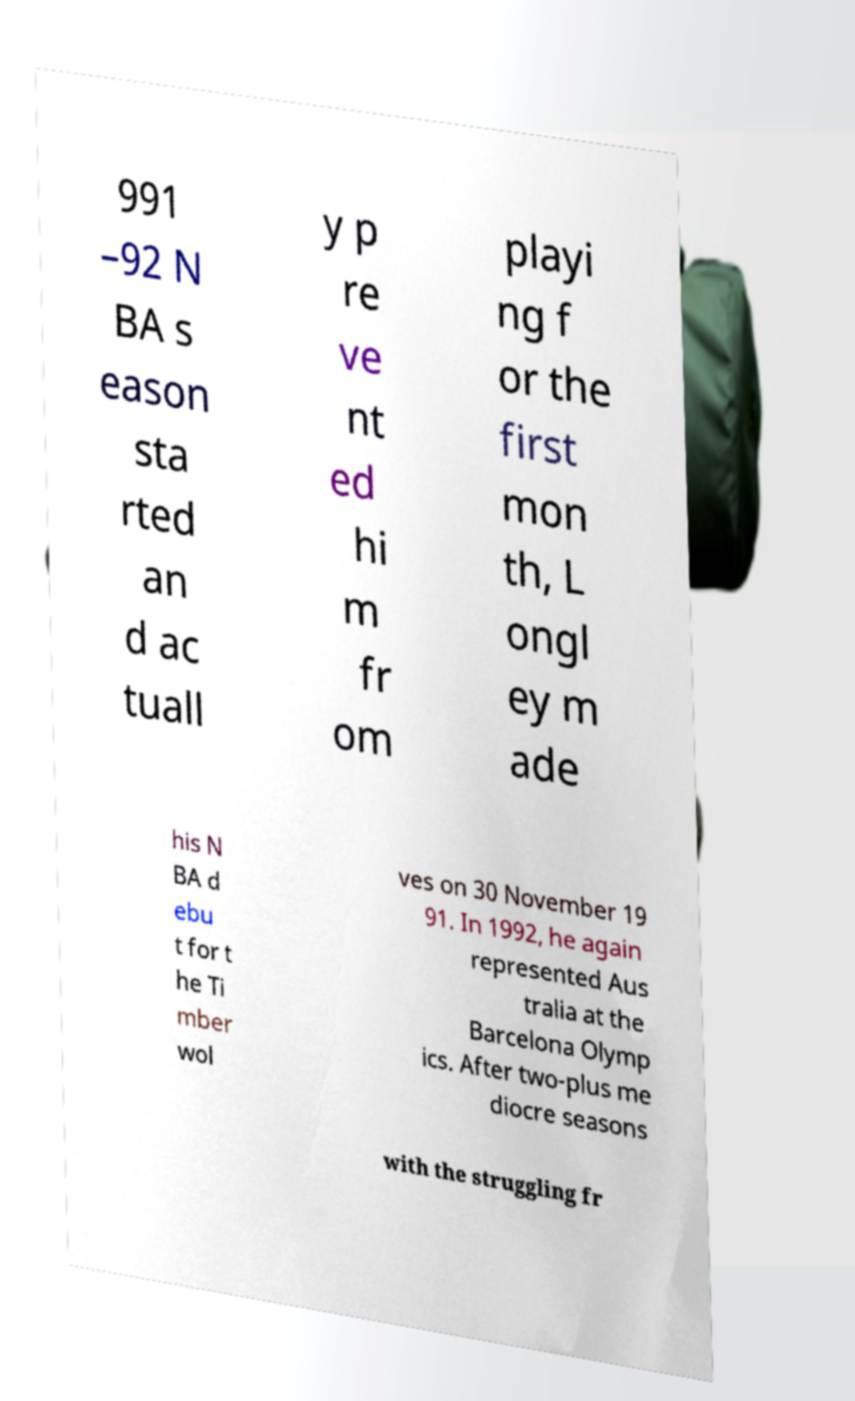Can you read and provide the text displayed in the image?This photo seems to have some interesting text. Can you extract and type it out for me? 991 –92 N BA s eason sta rted an d ac tuall y p re ve nt ed hi m fr om playi ng f or the first mon th, L ongl ey m ade his N BA d ebu t for t he Ti mber wol ves on 30 November 19 91. In 1992, he again represented Aus tralia at the Barcelona Olymp ics. After two-plus me diocre seasons with the struggling fr 